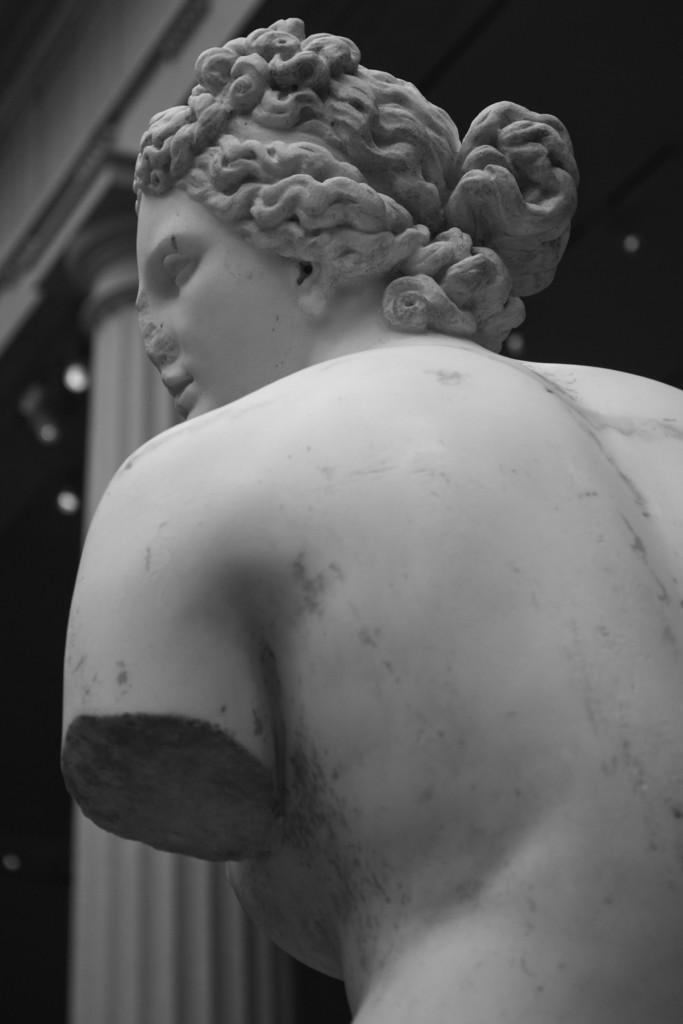In one or two sentences, can you explain what this image depicts? This is a black and white image. In the center of the image we can see a mannequin. In the background of the image we can see the wall, pillar, lights. At the top of the image we can see the roof. 